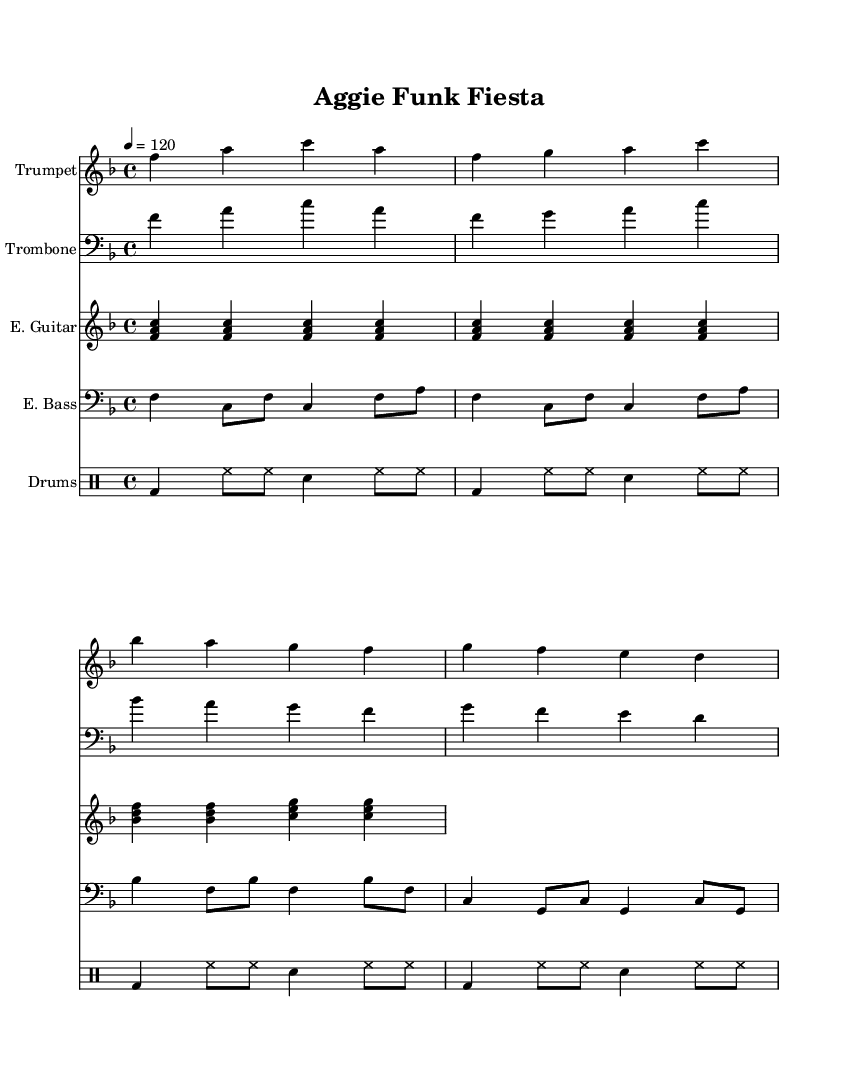What is the key signature of this music? The key signature identified in the sheet music is F major, which has one flat (B♭). This can be determined by observing the key signature placed at the beginning of the score.
Answer: F major What is the time signature of the piece? The time signature is 4/4, indicated at the beginning of the music. This means there are four beats per measure and a quarter note gets one beat.
Answer: 4/4 What is the tempo marking for this music? The tempo marking in the sheet music is indicated as 4 = 120, which specifies the beat tempo in quarter notes per minute, providing a lively pace for the performance.
Answer: 120 How many measures are in the trumpet part? By counting the measures in the trumpet staff section, there are 8 measures in total. Each group of vertical lines represents a measure, and they can be counted to determine the total.
Answer: 8 Which instruments are featured in this piece? The score showcases a trumpet, trombone, electric guitar, electric bass, and drums, all listed in the staff names. This information can be found in the header of each instrument staff setup.
Answer: Trumpet, Trombone, Electric Guitar, Electric Bass, Drums What rhythmic figures are predominantly used in the electric bass part? The electric bass part features predominantly quarter notes and eighth notes. This can be determined by analyzing the note shapes and their placement in the measure.
Answer: Quarter notes and eighth notes What musical genre does this piece represent? This piece represents a funk-latin fusion genre, characterized by energetic rhythms and a lively feel, indicative of the styles popular during the 1980s. This can be inferred from the lively tempo and instrumentation typical of funk music.
Answer: Funk-Latin fusion 